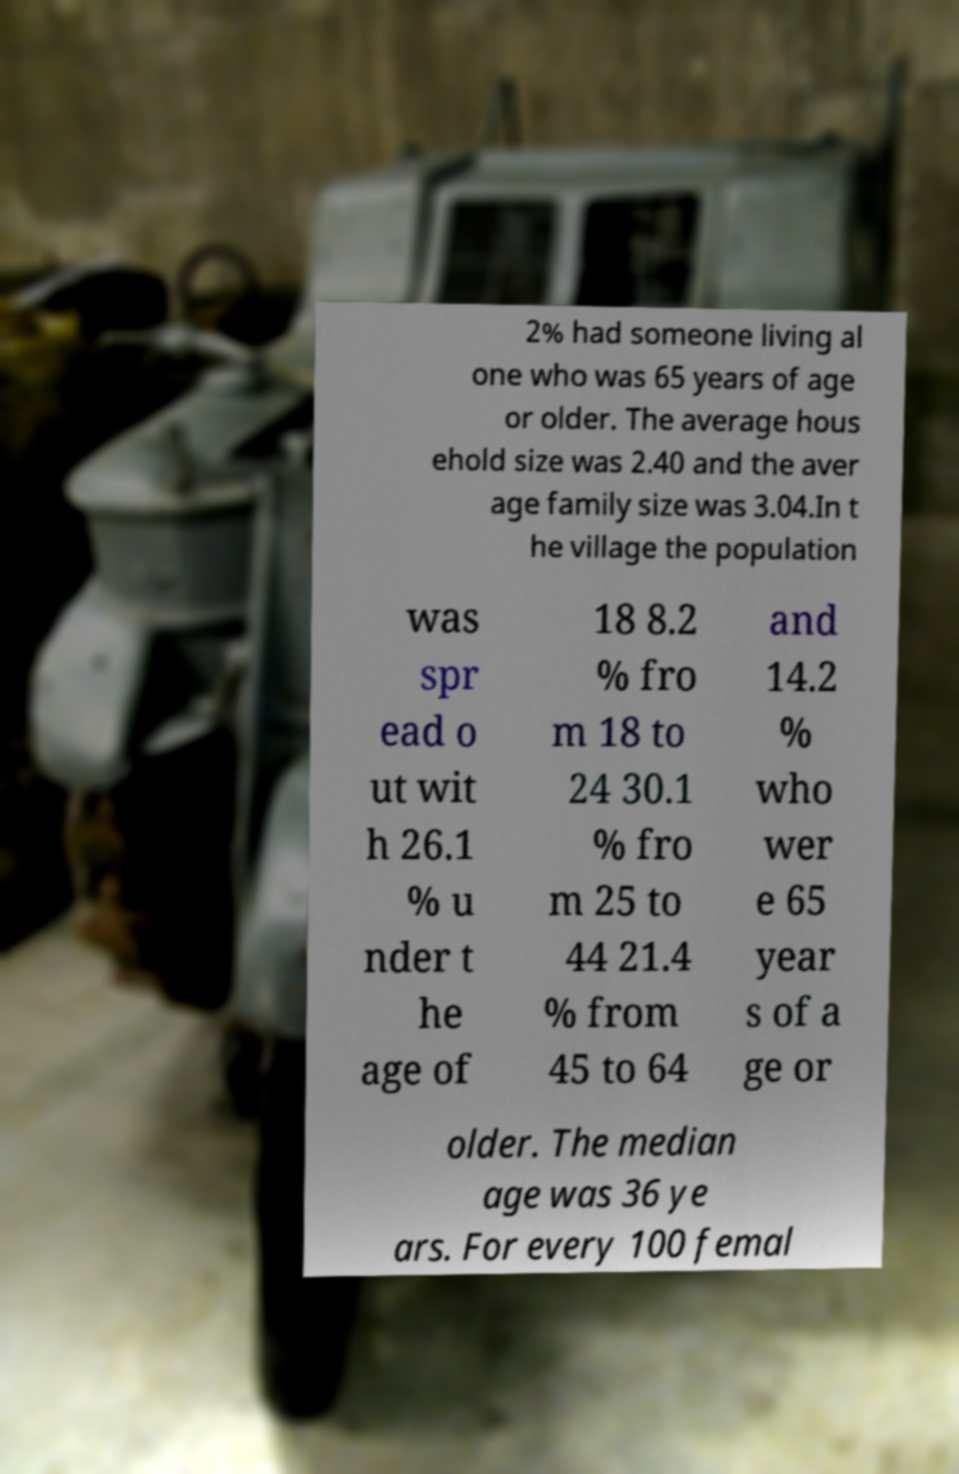Please read and relay the text visible in this image. What does it say? 2% had someone living al one who was 65 years of age or older. The average hous ehold size was 2.40 and the aver age family size was 3.04.In t he village the population was spr ead o ut wit h 26.1 % u nder t he age of 18 8.2 % fro m 18 to 24 30.1 % fro m 25 to 44 21.4 % from 45 to 64 and 14.2 % who wer e 65 year s of a ge or older. The median age was 36 ye ars. For every 100 femal 